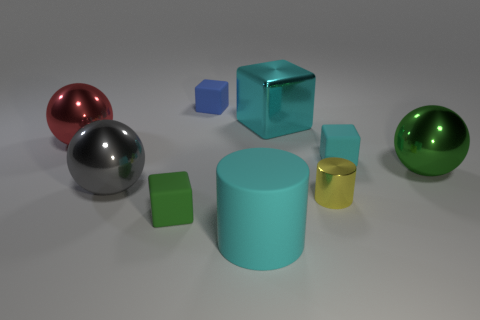There is a small thing to the right of the small yellow shiny cylinder; is its shape the same as the large red object?
Make the answer very short. No. The cyan thing that is the same material as the tiny cyan block is what size?
Your answer should be compact. Large. How many objects are either cyan matte objects behind the cyan cylinder or blocks that are right of the cyan metallic thing?
Your response must be concise. 1. Is the number of big gray metallic spheres right of the large metallic cube the same as the number of gray metallic spheres in front of the tiny yellow metallic cylinder?
Offer a terse response. Yes. What color is the large metallic ball that is on the right side of the tiny cyan block?
Make the answer very short. Green. There is a large metallic cube; does it have the same color as the object on the right side of the tiny cyan cube?
Provide a short and direct response. No. Are there fewer large green rubber things than matte cylinders?
Offer a terse response. Yes. There is a big sphere that is right of the green matte thing; does it have the same color as the metal block?
Provide a succinct answer. No. What number of green things are the same size as the red metallic object?
Your response must be concise. 1. Is there another block of the same color as the big cube?
Provide a short and direct response. Yes. 